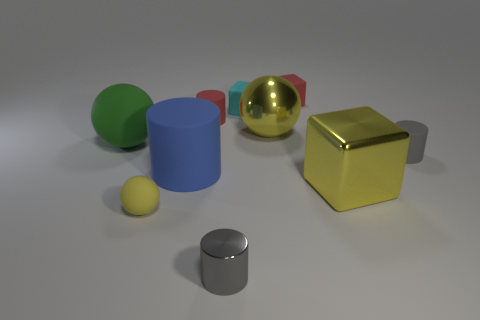Subtract 1 cylinders. How many cylinders are left? 3 Subtract all cylinders. How many objects are left? 6 Add 1 large metal things. How many large metal things exist? 3 Subtract 2 yellow balls. How many objects are left? 8 Subtract all small cyan blocks. Subtract all tiny cyan rubber blocks. How many objects are left? 8 Add 9 blue rubber things. How many blue rubber things are left? 10 